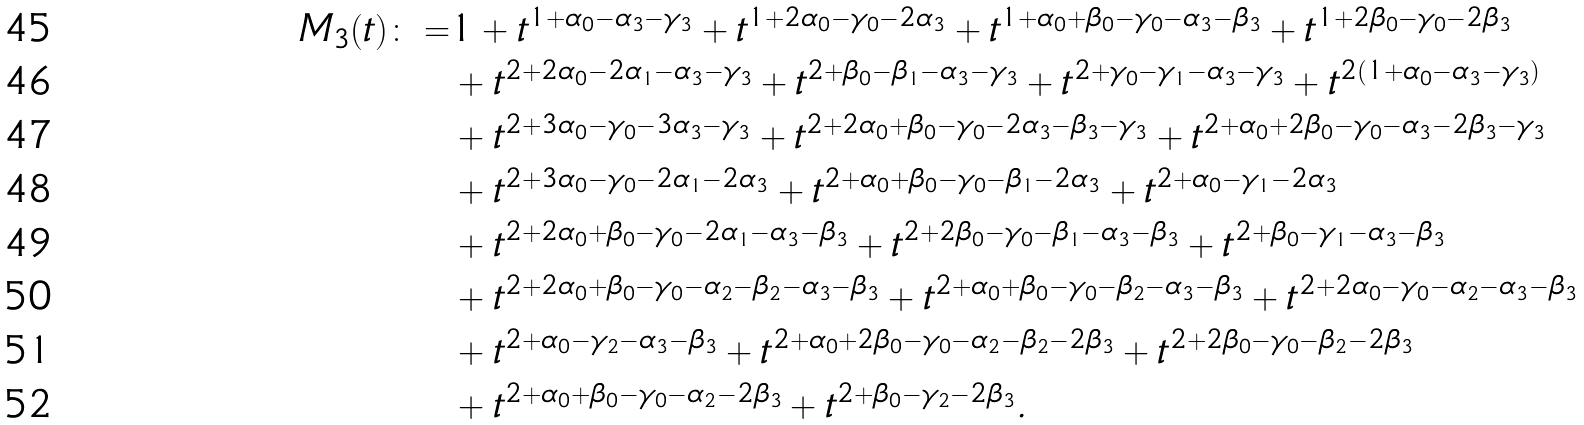<formula> <loc_0><loc_0><loc_500><loc_500>M _ { 3 } ( t ) \colon = & 1 + t ^ { 1 + \alpha _ { 0 } - \alpha _ { 3 } - \gamma _ { 3 } } + t ^ { 1 + 2 \alpha _ { 0 } - \gamma _ { 0 } - 2 \alpha _ { 3 } } + t ^ { 1 + \alpha _ { 0 } + \beta _ { 0 } - \gamma _ { 0 } - \alpha _ { 3 } - \beta _ { 3 } } + t ^ { 1 + 2 \beta _ { 0 } - \gamma _ { 0 } - 2 \beta _ { 3 } } \\ & + t ^ { 2 + 2 \alpha _ { 0 } - 2 \alpha _ { 1 } - \alpha _ { 3 } - \gamma _ { 3 } } + t ^ { 2 + \beta _ { 0 } - \beta _ { 1 } - \alpha _ { 3 } - \gamma _ { 3 } } + t ^ { 2 + \gamma _ { 0 } - \gamma _ { 1 } - \alpha _ { 3 } - \gamma _ { 3 } } + t ^ { 2 ( 1 + \alpha _ { 0 } - \alpha _ { 3 } - \gamma _ { 3 } ) } \\ & + t ^ { 2 + 3 \alpha _ { 0 } - \gamma _ { 0 } - 3 \alpha _ { 3 } - \gamma _ { 3 } } + t ^ { 2 + 2 \alpha _ { 0 } + \beta _ { 0 } - \gamma _ { 0 } - 2 \alpha _ { 3 } - \beta _ { 3 } - \gamma _ { 3 } } + t ^ { 2 + \alpha _ { 0 } + 2 \beta _ { 0 } - \gamma _ { 0 } - \alpha _ { 3 } - 2 \beta _ { 3 } - \gamma _ { 3 } } \\ & + t ^ { 2 + 3 \alpha _ { 0 } - \gamma _ { 0 } - 2 \alpha _ { 1 } - 2 \alpha _ { 3 } } + t ^ { 2 + \alpha _ { 0 } + \beta _ { 0 } - \gamma _ { 0 } - \beta _ { 1 } - 2 \alpha _ { 3 } } + t ^ { 2 + \alpha _ { 0 } - \gamma _ { 1 } - 2 \alpha _ { 3 } } \\ & + t ^ { 2 + 2 \alpha _ { 0 } + \beta _ { 0 } - \gamma _ { 0 } - 2 \alpha _ { 1 } - \alpha _ { 3 } - \beta _ { 3 } } + t ^ { 2 + 2 \beta _ { 0 } - \gamma _ { 0 } - \beta _ { 1 } - \alpha _ { 3 } - \beta _ { 3 } } + t ^ { 2 + \beta _ { 0 } - \gamma _ { 1 } - \alpha _ { 3 } - \beta _ { 3 } } \\ & + t ^ { 2 + 2 \alpha _ { 0 } + \beta _ { 0 } - \gamma _ { 0 } - \alpha _ { 2 } - \beta _ { 2 } - \alpha _ { 3 } - \beta _ { 3 } } + t ^ { 2 + \alpha _ { 0 } + \beta _ { 0 } - \gamma _ { 0 } - \beta _ { 2 } - \alpha _ { 3 } - \beta _ { 3 } } + t ^ { 2 + 2 \alpha _ { 0 } - \gamma _ { 0 } - \alpha _ { 2 } - \alpha _ { 3 } - \beta _ { 3 } } \\ & + t ^ { 2 + \alpha _ { 0 } - \gamma _ { 2 } - \alpha _ { 3 } - \beta _ { 3 } } + t ^ { 2 + \alpha _ { 0 } + 2 \beta _ { 0 } - \gamma _ { 0 } - \alpha _ { 2 } - \beta _ { 2 } - 2 \beta _ { 3 } } + t ^ { 2 + 2 \beta _ { 0 } - \gamma _ { 0 } - \beta _ { 2 } - 2 \beta _ { 3 } } \\ & + t ^ { 2 + \alpha _ { 0 } + \beta _ { 0 } - \gamma _ { 0 } - \alpha _ { 2 } - 2 \beta _ { 3 } } + t ^ { 2 + \beta _ { 0 } - \gamma _ { 2 } - 2 \beta _ { 3 } } .</formula> 